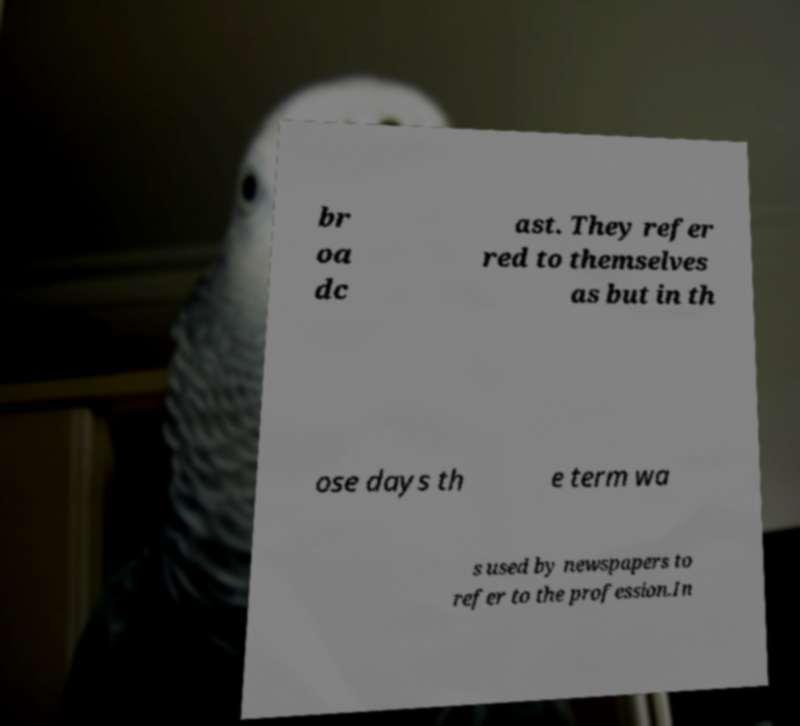What messages or text are displayed in this image? I need them in a readable, typed format. br oa dc ast. They refer red to themselves as but in th ose days th e term wa s used by newspapers to refer to the profession.In 